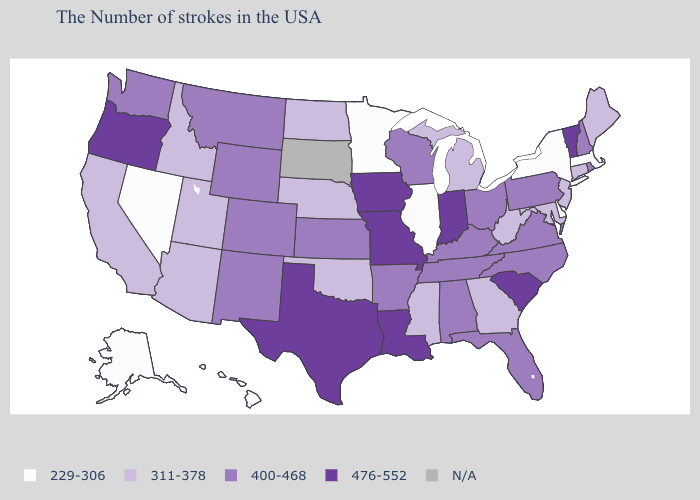What is the value of Maryland?
Keep it brief. 311-378. Does Virginia have the highest value in the South?
Be succinct. No. What is the value of Rhode Island?
Be succinct. 400-468. What is the lowest value in the USA?
Be succinct. 229-306. Name the states that have a value in the range 476-552?
Short answer required. Vermont, South Carolina, Indiana, Louisiana, Missouri, Iowa, Texas, Oregon. Among the states that border Massachusetts , which have the highest value?
Concise answer only. Vermont. What is the value of Virginia?
Keep it brief. 400-468. Does the first symbol in the legend represent the smallest category?
Give a very brief answer. Yes. Name the states that have a value in the range N/A?
Quick response, please. South Dakota. What is the value of Wyoming?
Answer briefly. 400-468. What is the value of Tennessee?
Keep it brief. 400-468. Does the first symbol in the legend represent the smallest category?
Quick response, please. Yes. Name the states that have a value in the range N/A?
Concise answer only. South Dakota. What is the highest value in the USA?
Give a very brief answer. 476-552. Among the states that border Illinois , which have the lowest value?
Concise answer only. Kentucky, Wisconsin. 